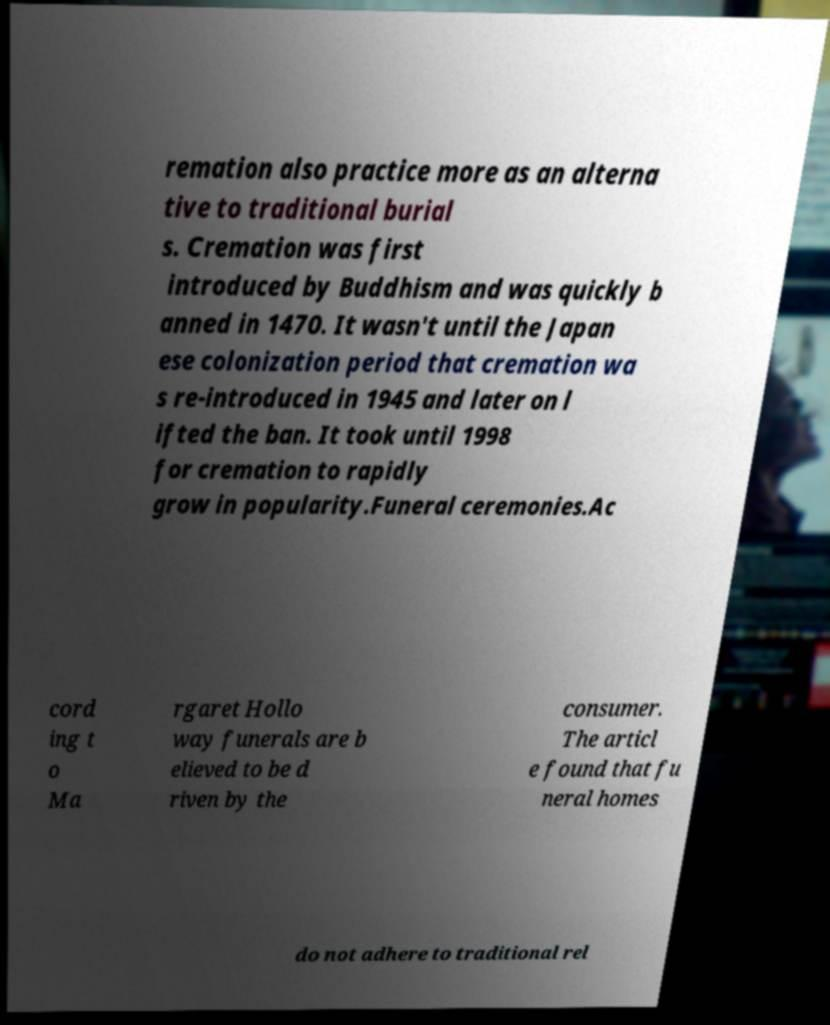Please identify and transcribe the text found in this image. remation also practice more as an alterna tive to traditional burial s. Cremation was first introduced by Buddhism and was quickly b anned in 1470. It wasn't until the Japan ese colonization period that cremation wa s re-introduced in 1945 and later on l ifted the ban. It took until 1998 for cremation to rapidly grow in popularity.Funeral ceremonies.Ac cord ing t o Ma rgaret Hollo way funerals are b elieved to be d riven by the consumer. The articl e found that fu neral homes do not adhere to traditional rel 